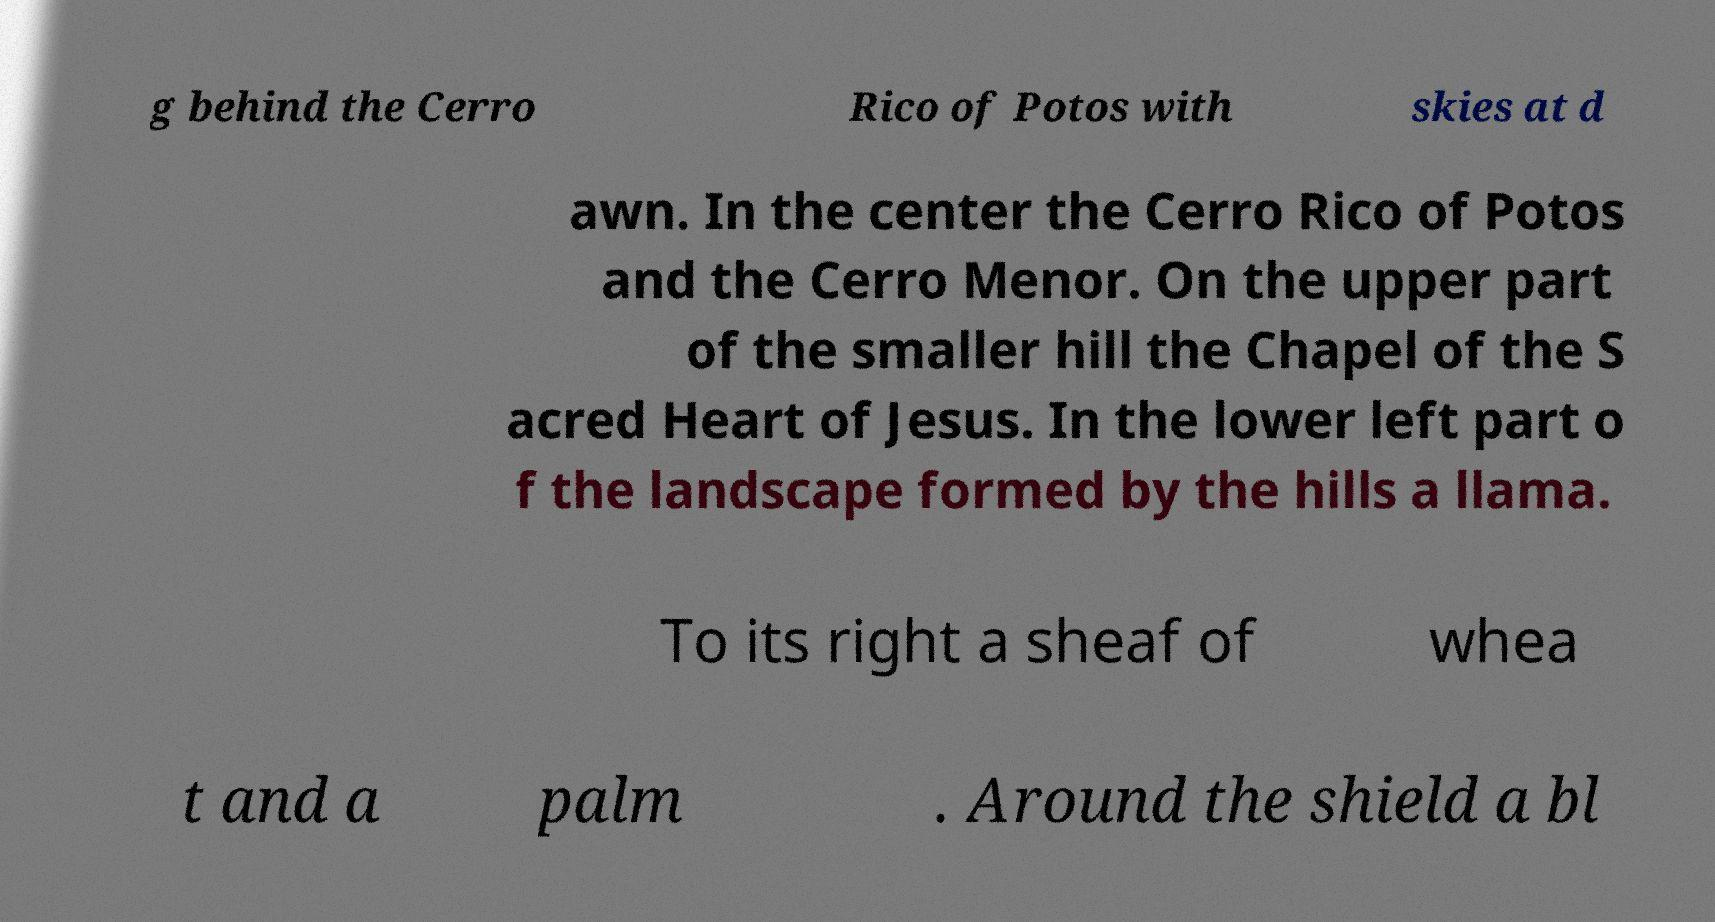What messages or text are displayed in this image? I need them in a readable, typed format. g behind the Cerro Rico of Potos with skies at d awn. In the center the Cerro Rico of Potos and the Cerro Menor. On the upper part of the smaller hill the Chapel of the S acred Heart of Jesus. In the lower left part o f the landscape formed by the hills a llama. To its right a sheaf of whea t and a palm . Around the shield a bl 